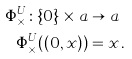<formula> <loc_0><loc_0><loc_500><loc_500>\Phi _ { \times } ^ { U } \colon \{ 0 \} \times a & \rightarrow a \\ \Phi _ { \times } ^ { U } ( ( 0 , x ) ) & = x \, .</formula> 